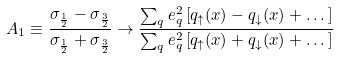<formula> <loc_0><loc_0><loc_500><loc_500>A _ { 1 } \equiv \frac { \sigma _ { \frac { 1 } { 2 } } - \sigma _ { \frac { 3 } { 2 } } } { \sigma _ { \frac { 1 } { 2 } } + \sigma _ { \frac { 3 } { 2 } } } \rightarrow \frac { \sum _ { q } e ^ { 2 } _ { q } \left [ q _ { \uparrow } ( x ) - q _ { \downarrow } ( x ) + \dots \right ] } { \sum _ { q } e ^ { 2 } _ { q } \left [ q _ { \uparrow } ( x ) + q _ { \downarrow } ( x ) + \dots \right ] }</formula> 